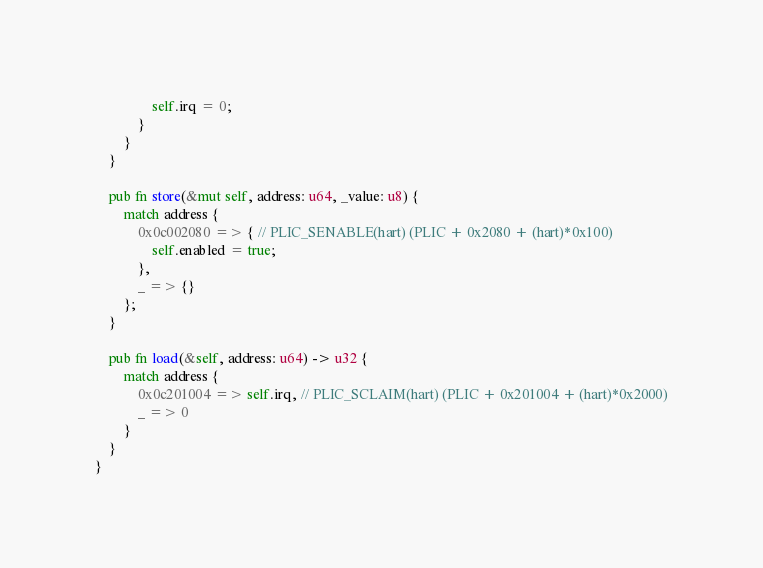<code> <loc_0><loc_0><loc_500><loc_500><_Rust_>				self.irq = 0;
			}
		}
	}

	pub fn store(&mut self, address: u64, _value: u8) {
		match address {
			0x0c002080 => { // PLIC_SENABLE(hart) (PLIC + 0x2080 + (hart)*0x100)
				self.enabled = true;
			},
			_ => {}
		};
	}

	pub fn load(&self, address: u64) -> u32 {
		match address {
			0x0c201004 => self.irq, // PLIC_SCLAIM(hart) (PLIC + 0x201004 + (hart)*0x2000)
			_ => 0
		}
	}
}
</code> 